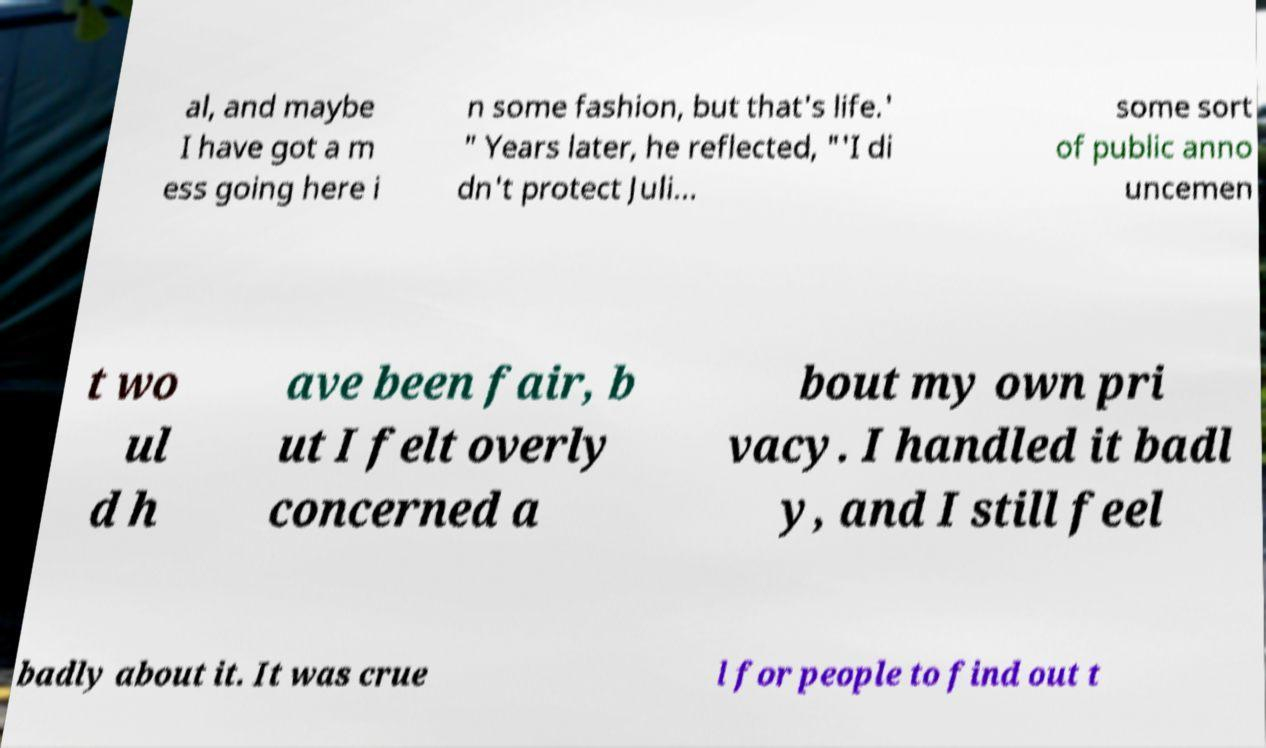There's text embedded in this image that I need extracted. Can you transcribe it verbatim? al, and maybe I have got a m ess going here i n some fashion, but that's life.' " Years later, he reflected, "'I di dn't protect Juli... some sort of public anno uncemen t wo ul d h ave been fair, b ut I felt overly concerned a bout my own pri vacy. I handled it badl y, and I still feel badly about it. It was crue l for people to find out t 